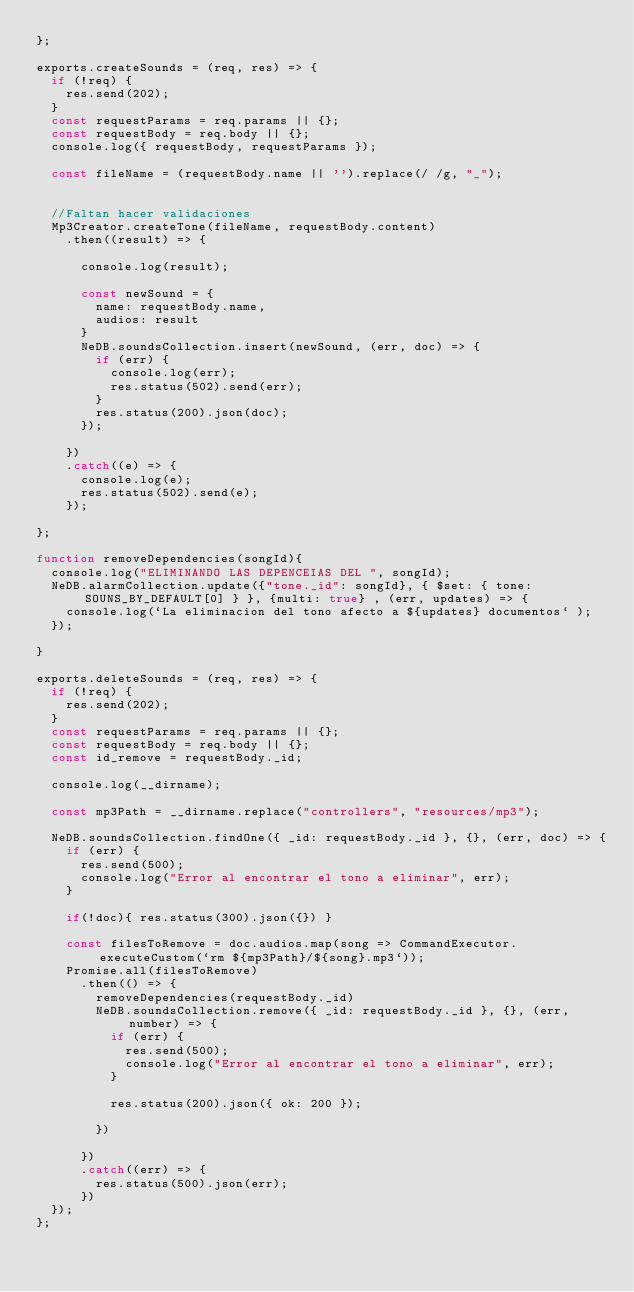<code> <loc_0><loc_0><loc_500><loc_500><_JavaScript_>};

exports.createSounds = (req, res) => {
  if (!req) {
    res.send(202);
  }
  const requestParams = req.params || {};
  const requestBody = req.body || {};
  console.log({ requestBody, requestParams });

  const fileName = (requestBody.name || '').replace(/ /g, "_");


  //Faltan hacer validaciones 
  Mp3Creator.createTone(fileName, requestBody.content)
    .then((result) => {

      console.log(result);

      const newSound = {
        name: requestBody.name,
        audios: result
      }
      NeDB.soundsCollection.insert(newSound, (err, doc) => {
        if (err) {
          console.log(err);
          res.status(502).send(err);
        }
        res.status(200).json(doc);
      });

    })
    .catch((e) => {
      console.log(e);
      res.status(502).send(e);
    });

};

function removeDependencies(songId){
  console.log("ELIMINANDO LAS DEPENCEIAS DEL ", songId);
  NeDB.alarmCollection.update({"tone._id": songId}, { $set: { tone: SOUNS_BY_DEFAULT[0] } }, {multi: true} , (err, updates) => {
    console.log(`La eliminacion del tono afecto a ${updates} documentos` );
  });

}

exports.deleteSounds = (req, res) => {
  if (!req) {
    res.send(202);
  }
  const requestParams = req.params || {};
  const requestBody = req.body || {};
  const id_remove = requestBody._id;

  console.log(__dirname);

  const mp3Path = __dirname.replace("controllers", "resources/mp3");

  NeDB.soundsCollection.findOne({ _id: requestBody._id }, {}, (err, doc) => {
    if (err) {
      res.send(500);
      console.log("Error al encontrar el tono a eliminar", err);
    }

    if(!doc){ res.status(300).json({}) }

    const filesToRemove = doc.audios.map(song => CommandExecutor.executeCustom(`rm ${mp3Path}/${song}.mp3`));
    Promise.all(filesToRemove)
      .then(() => {
        removeDependencies(requestBody._id)
        NeDB.soundsCollection.remove({ _id: requestBody._id }, {}, (err, number) => {
          if (err) {
            res.send(500);
            console.log("Error al encontrar el tono a eliminar", err);
          }

          res.status(200).json({ ok: 200 });

        })

      })
      .catch((err) => {
        res.status(500).json(err);
      })
  });
};


</code> 